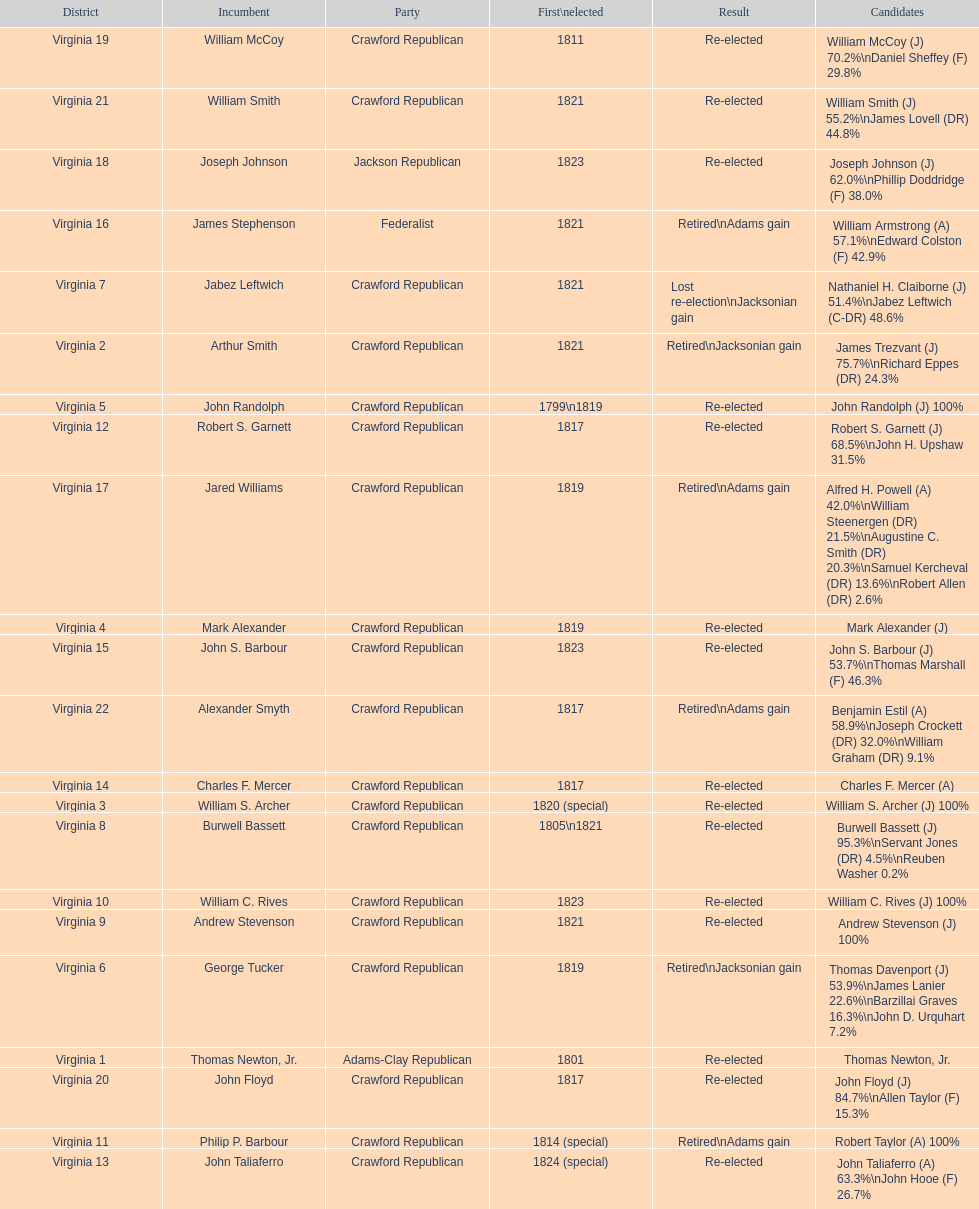Specify the only aspirant who was elected for the first time in 181 William McCoy. 